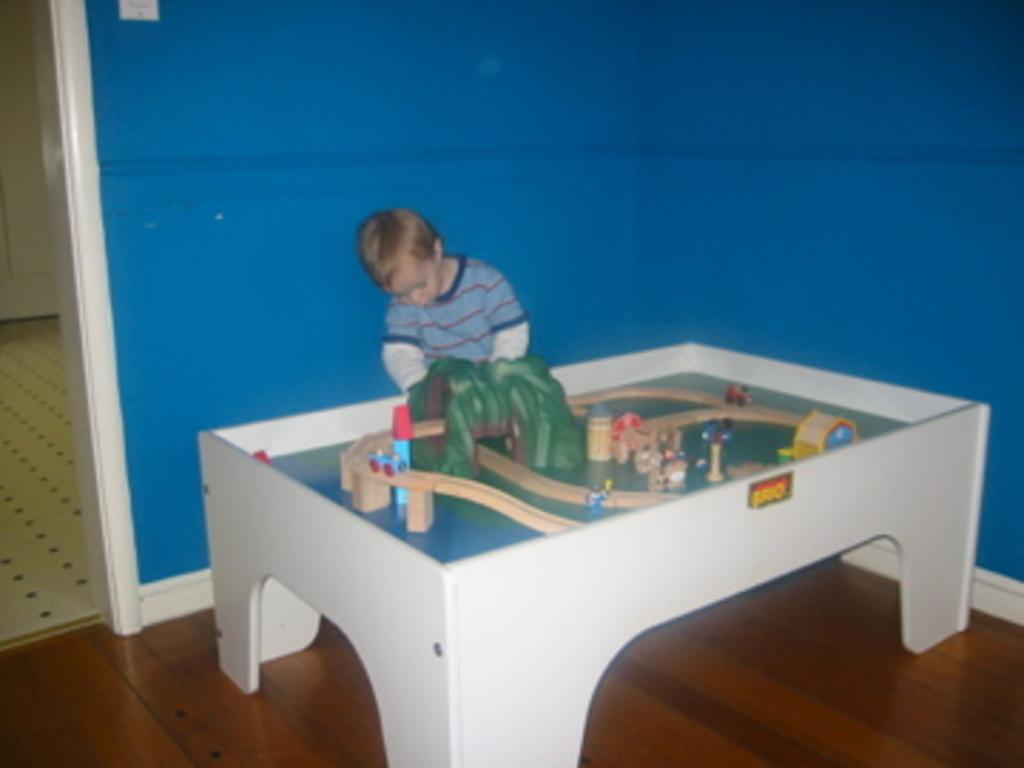What is the main subject of the image? The main subject of the image is a child. What else can be seen in the image besides the child? There is a miniature in the image. What type of guitar is the queen playing in the image? There is no guitar or queen present in the image; it only features a child and a miniature. 